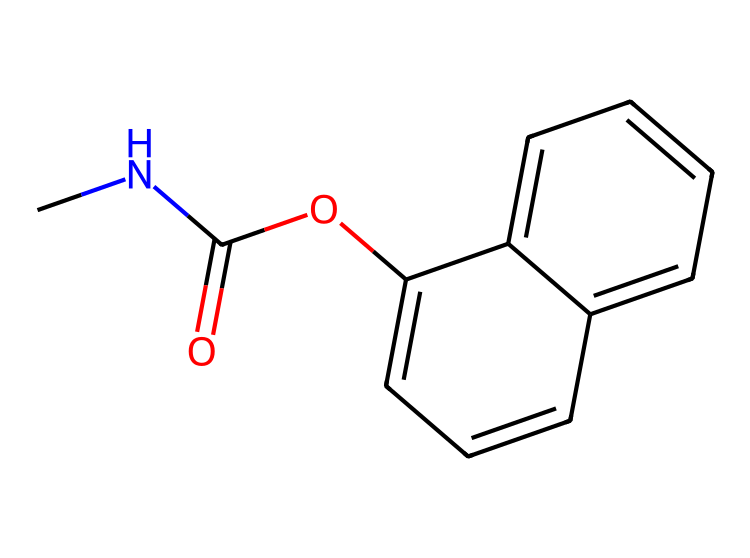What is the primary functional group in carbaryl? The SMILES representation shows a carbonyl group (C=O) attached to an oxygen (O) in the structure, indicating that the primary functional group in carbaryl is an ester.
Answer: ester How many carbon atoms are present in carbaryl? By examining the structure represented in the SMILES, we can count a total of 12 carbon atoms in the chemical.
Answer: 12 What is the total number of nitrogen atoms in carbaryl? The SMILES shows one nitrogen atom present in the chemical structure, which indicates that carbaryl contains one nitrogen atom.
Answer: 1 Is carbaryl classified as an organophosphate? Carbaryl has a carbamate structure as indicated by its functional groups, and it clearly does not fall into the organophosphate category.
Answer: no What type of chemical is carbaryl primarily used as? Considering its function and the presence of a carbamate group in the structure, carbaryl is primarily used as a pesticide for controlling pests, particularly insects.
Answer: pesticide Which part of the structure contributes to the inhibitory effect on acetylcholinesterase? The carbamate functional group (specifically the -O-C(=O)-N- bond) is responsible for binding to the acetylcholinesterase enzyme, leading to its inhibitory effect.
Answer: carbamate group 